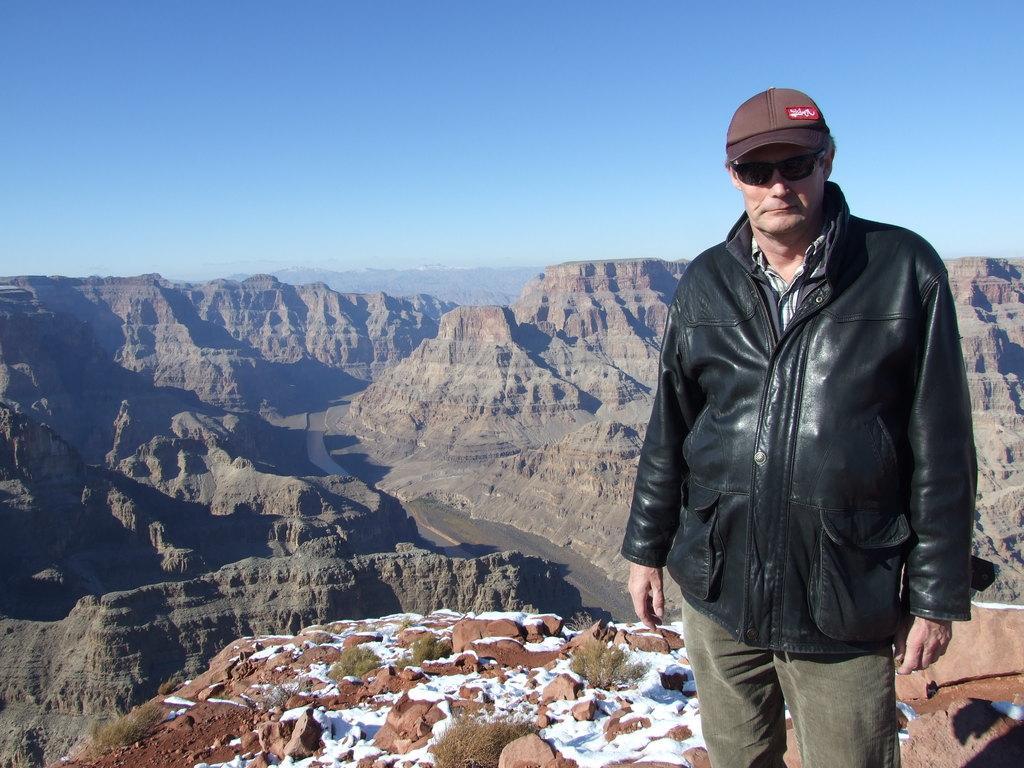In one or two sentences, can you explain what this image depicts? In this image in the right one man wearing black jacket, cap and glasses is standing. On the ground there are shrubs, stones , snow. In the background there are hills. The sky is clear. 